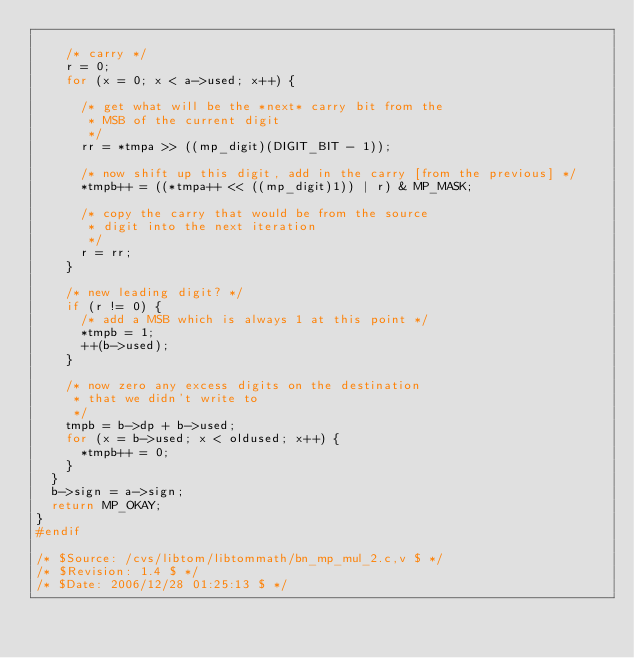Convert code to text. <code><loc_0><loc_0><loc_500><loc_500><_C_>
    /* carry */
    r = 0;
    for (x = 0; x < a->used; x++) {
    
      /* get what will be the *next* carry bit from the 
       * MSB of the current digit 
       */
      rr = *tmpa >> ((mp_digit)(DIGIT_BIT - 1));
      
      /* now shift up this digit, add in the carry [from the previous] */
      *tmpb++ = ((*tmpa++ << ((mp_digit)1)) | r) & MP_MASK;
      
      /* copy the carry that would be from the source 
       * digit into the next iteration 
       */
      r = rr;
    }

    /* new leading digit? */
    if (r != 0) {
      /* add a MSB which is always 1 at this point */
      *tmpb = 1;
      ++(b->used);
    }

    /* now zero any excess digits on the destination 
     * that we didn't write to 
     */
    tmpb = b->dp + b->used;
    for (x = b->used; x < oldused; x++) {
      *tmpb++ = 0;
    }
  }
  b->sign = a->sign;
  return MP_OKAY;
}
#endif

/* $Source: /cvs/libtom/libtommath/bn_mp_mul_2.c,v $ */
/* $Revision: 1.4 $ */
/* $Date: 2006/12/28 01:25:13 $ */
</code> 